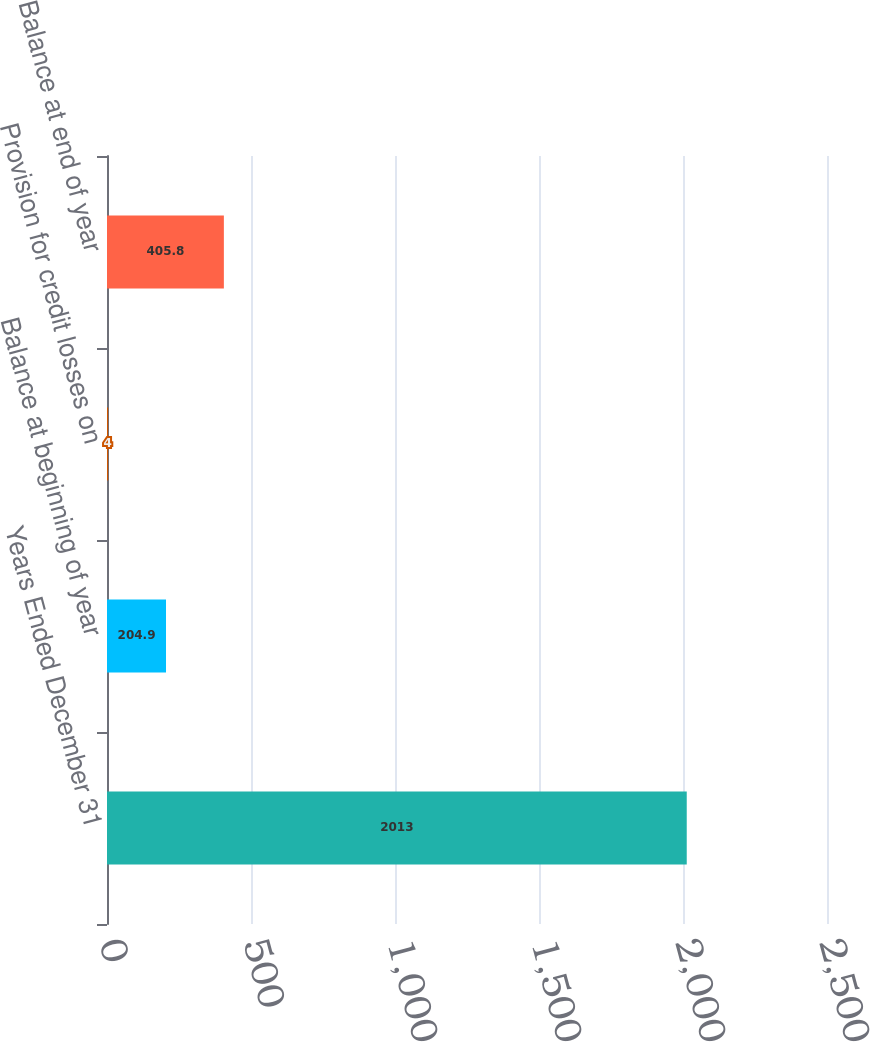Convert chart to OTSL. <chart><loc_0><loc_0><loc_500><loc_500><bar_chart><fcel>Years Ended December 31<fcel>Balance at beginning of year<fcel>Provision for credit losses on<fcel>Balance at end of year<nl><fcel>2013<fcel>204.9<fcel>4<fcel>405.8<nl></chart> 